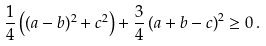Convert formula to latex. <formula><loc_0><loc_0><loc_500><loc_500>\frac { 1 } { 4 } \left ( ( a - b ) ^ { 2 } + c ^ { 2 } \right ) + \frac { 3 } { 4 } \left ( a + b - c \right ) ^ { 2 } \geq 0 \, .</formula> 